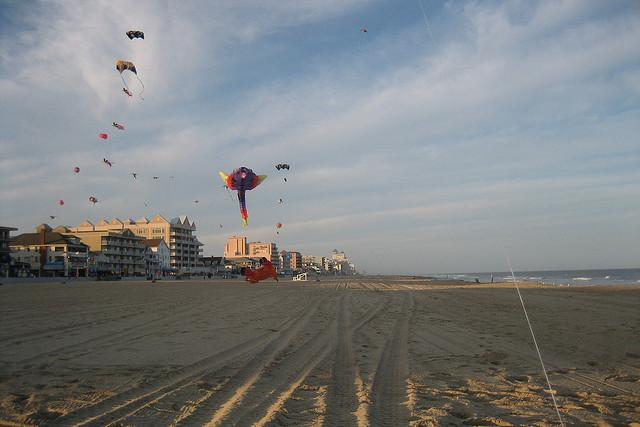Is there any road?
Keep it brief. No. There are mountains in the city?
Answer briefly. No. Are vehicles allowed on the beach?
Answer briefly. Yes. Is the sun up?
Write a very short answer. Yes. Where does the scene take place?
Keep it brief. Beach. What are the things in the sky?
Quick response, please. Kites. Was this taken on an island?
Write a very short answer. No. Are there any cars on the beach?
Keep it brief. No. Where is this?
Quick response, please. Beach. 